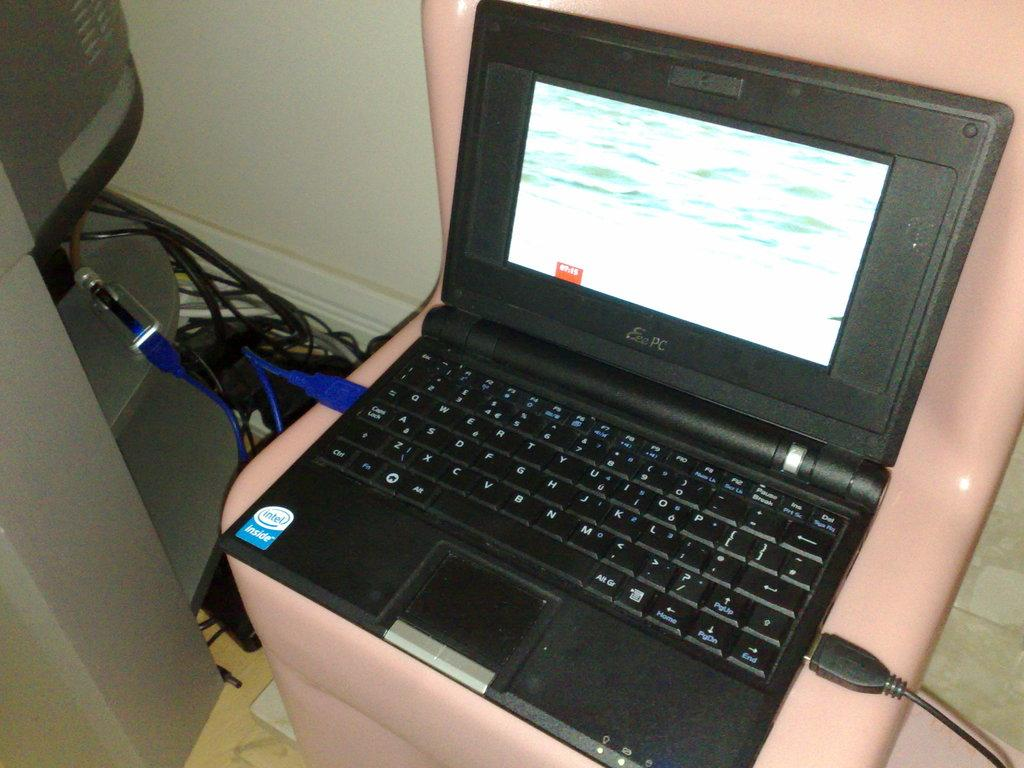<image>
Create a compact narrative representing the image presented. A laptop with a qwerty keyboard sitting on a chair. 